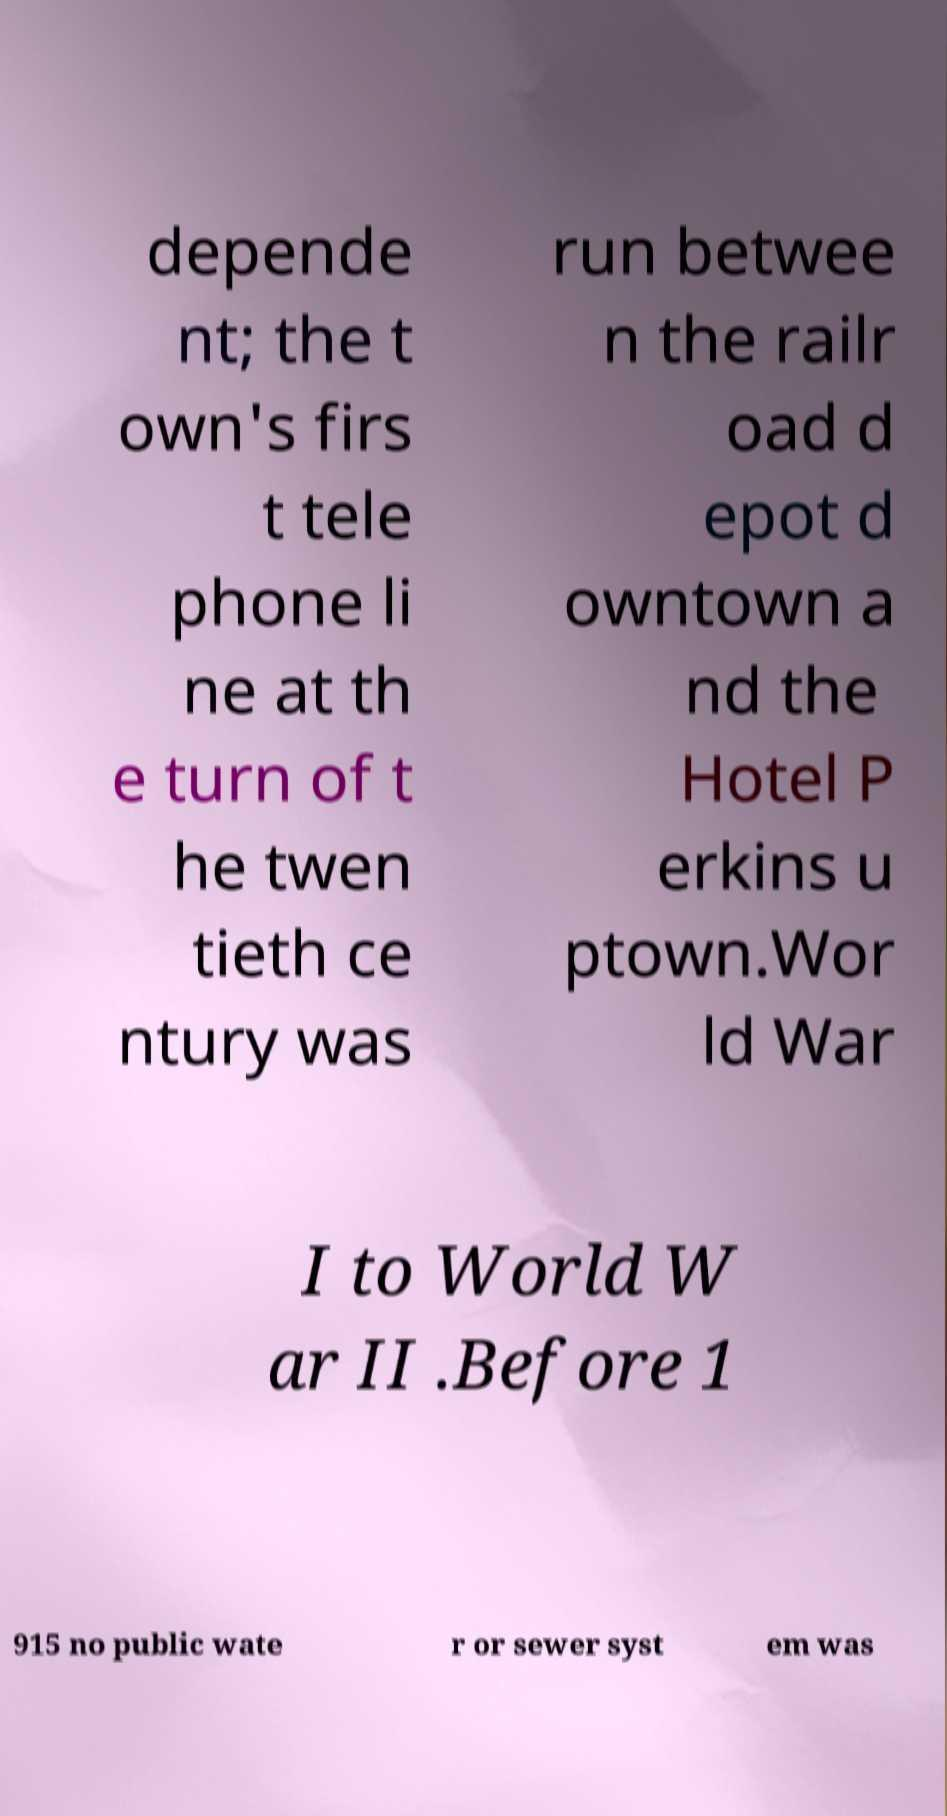Please read and relay the text visible in this image. What does it say? depende nt; the t own's firs t tele phone li ne at th e turn of t he twen tieth ce ntury was run betwee n the railr oad d epot d owntown a nd the Hotel P erkins u ptown.Wor ld War I to World W ar II .Before 1 915 no public wate r or sewer syst em was 